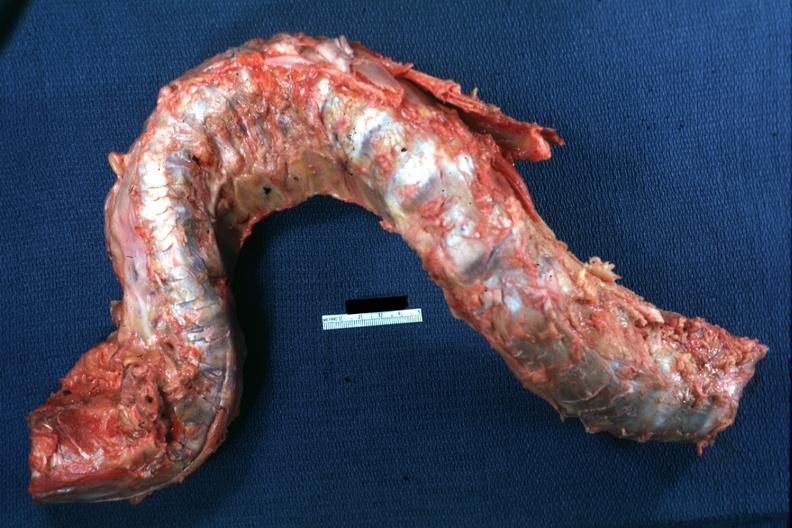s no cystic aortic lesions present?
Answer the question using a single word or phrase. No 